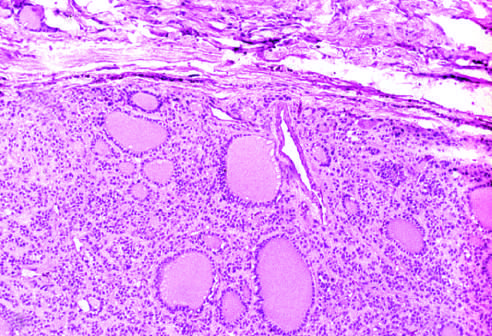what surrounds the neoplastic follicles?
Answer the question using a single word or phrase. A fibrous capsule 